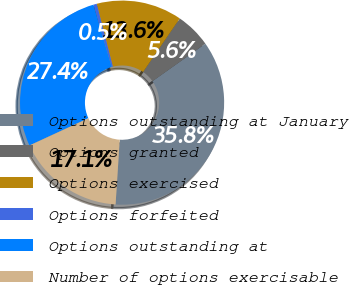Convert chart to OTSL. <chart><loc_0><loc_0><loc_500><loc_500><pie_chart><fcel>Options outstanding at January<fcel>Options granted<fcel>Options exercised<fcel>Options forfeited<fcel>Options outstanding at<fcel>Number of options exercisable<nl><fcel>35.82%<fcel>5.63%<fcel>13.56%<fcel>0.53%<fcel>27.36%<fcel>17.09%<nl></chart> 